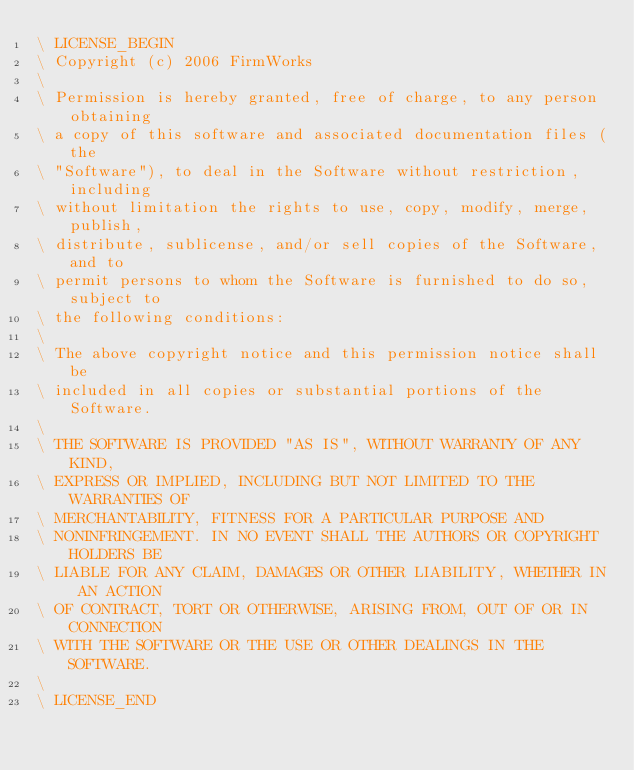<code> <loc_0><loc_0><loc_500><loc_500><_Forth_>\ LICENSE_BEGIN
\ Copyright (c) 2006 FirmWorks
\ 
\ Permission is hereby granted, free of charge, to any person obtaining
\ a copy of this software and associated documentation files (the
\ "Software"), to deal in the Software without restriction, including
\ without limitation the rights to use, copy, modify, merge, publish,
\ distribute, sublicense, and/or sell copies of the Software, and to
\ permit persons to whom the Software is furnished to do so, subject to
\ the following conditions:
\ 
\ The above copyright notice and this permission notice shall be
\ included in all copies or substantial portions of the Software.
\ 
\ THE SOFTWARE IS PROVIDED "AS IS", WITHOUT WARRANTY OF ANY KIND,
\ EXPRESS OR IMPLIED, INCLUDING BUT NOT LIMITED TO THE WARRANTIES OF
\ MERCHANTABILITY, FITNESS FOR A PARTICULAR PURPOSE AND
\ NONINFRINGEMENT. IN NO EVENT SHALL THE AUTHORS OR COPYRIGHT HOLDERS BE
\ LIABLE FOR ANY CLAIM, DAMAGES OR OTHER LIABILITY, WHETHER IN AN ACTION
\ OF CONTRACT, TORT OR OTHERWISE, ARISING FROM, OUT OF OR IN CONNECTION
\ WITH THE SOFTWARE OR THE USE OR OTHER DEALINGS IN THE SOFTWARE.
\
\ LICENSE_END
</code> 